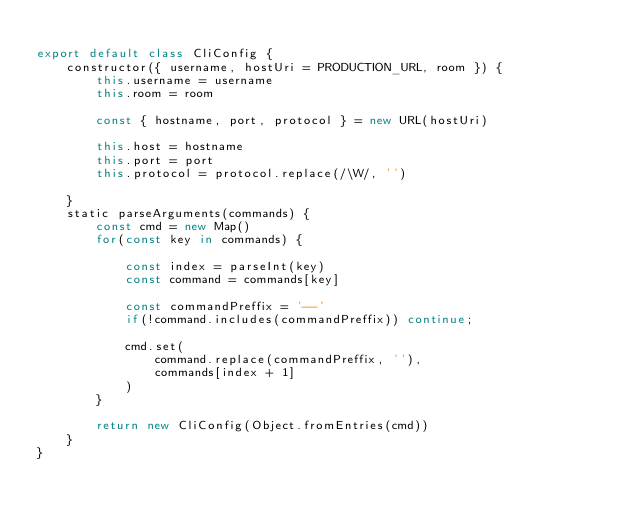<code> <loc_0><loc_0><loc_500><loc_500><_JavaScript_>
export default class CliConfig {
    constructor({ username, hostUri = PRODUCTION_URL, room }) {
        this.username = username
        this.room = room 

        const { hostname, port, protocol } = new URL(hostUri)

        this.host = hostname
        this.port = port
        this.protocol = protocol.replace(/\W/, '')
        
    }
    static parseArguments(commands) {
        const cmd = new Map()
        for(const key in commands) {

            const index = parseInt(key)
            const command = commands[key]

            const commandPreffix = '--'
            if(!command.includes(commandPreffix)) continue;
            
            cmd.set(
                command.replace(commandPreffix, ''),
                commands[index + 1]
            )
        }

        return new CliConfig(Object.fromEntries(cmd))
    }
}</code> 